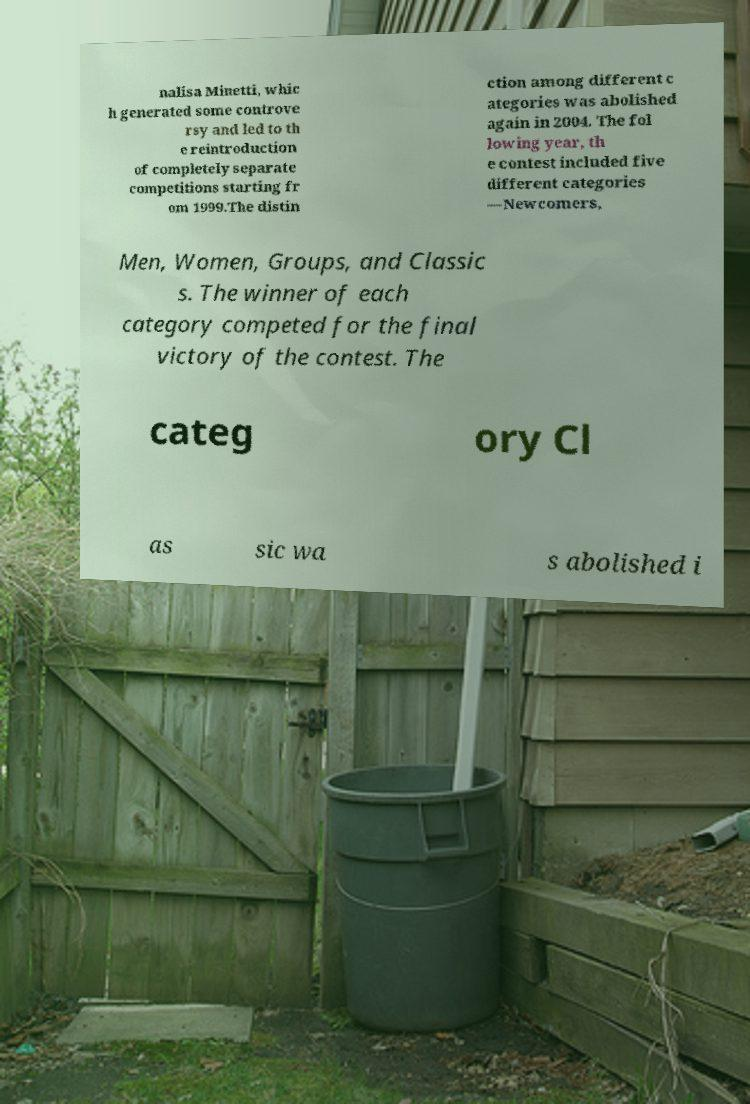Please read and relay the text visible in this image. What does it say? nalisa Minetti, whic h generated some controve rsy and led to th e reintroduction of completely separate competitions starting fr om 1999.The distin ction among different c ategories was abolished again in 2004. The fol lowing year, th e contest included five different categories —Newcomers, Men, Women, Groups, and Classic s. The winner of each category competed for the final victory of the contest. The categ ory Cl as sic wa s abolished i 